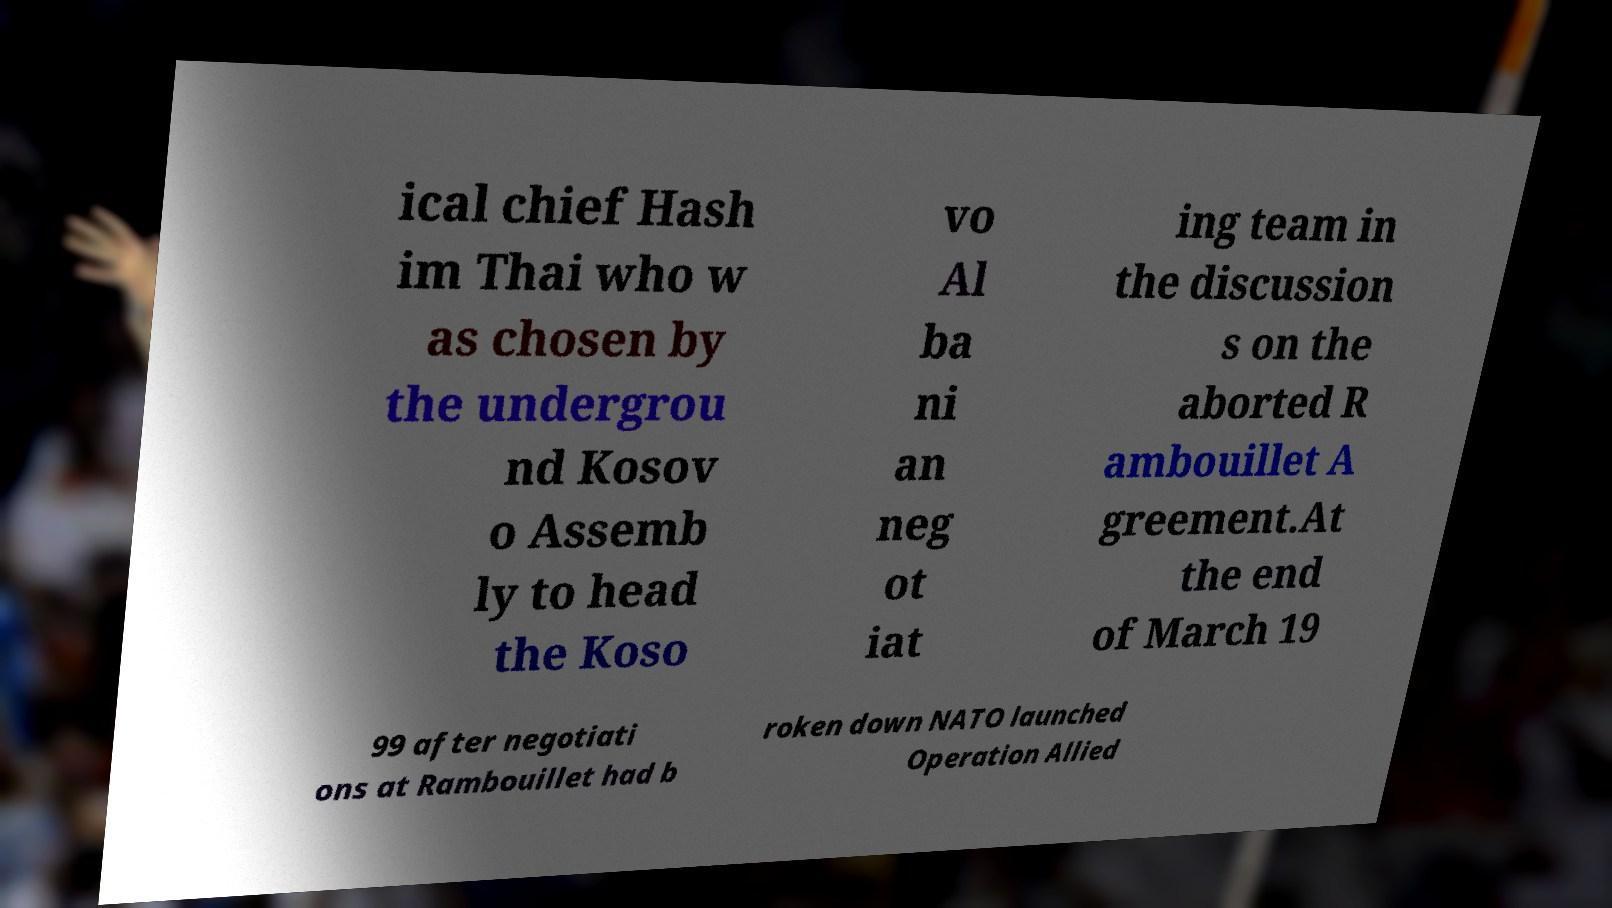Could you extract and type out the text from this image? ical chief Hash im Thai who w as chosen by the undergrou nd Kosov o Assemb ly to head the Koso vo Al ba ni an neg ot iat ing team in the discussion s on the aborted R ambouillet A greement.At the end of March 19 99 after negotiati ons at Rambouillet had b roken down NATO launched Operation Allied 